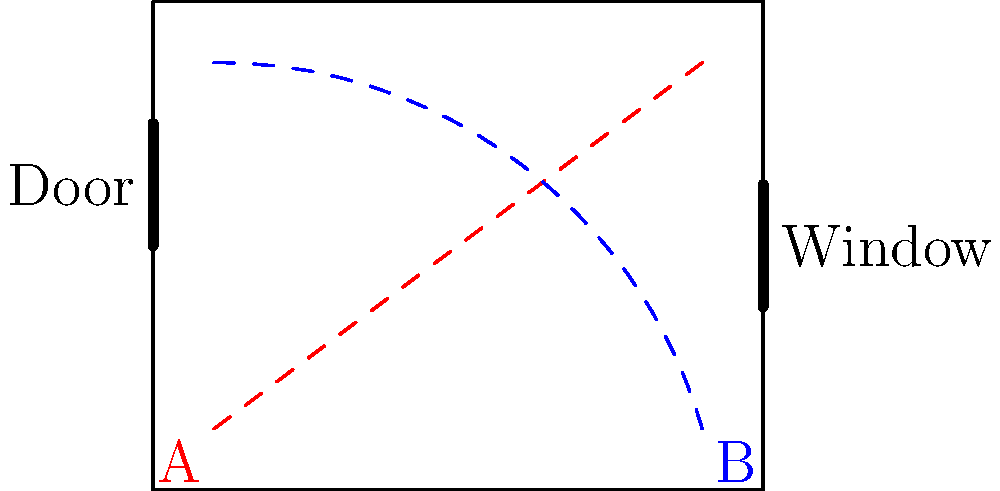In the floor plan diagram of a key film set, two characters' movement patterns are shown. Character A's path is represented by the red dashed line, while Character B's path is shown in blue. Based on these movement patterns, what cinematic technique is likely being employed to create narrative tension, and how does the set layout contribute to this effect? To answer this question, we need to analyze the movement patterns and set layout:

1. Character paths:
   - Character A (red) moves from the bottom-left to the top-right.
   - Character B (blue) moves from the bottom-right to the top-left.

2. Set layout:
   - The room has a door on the left side and a window on the right side.
   - The characters' paths intersect near the center of the room.

3. Cinematic technique analysis:
   - The crossing paths suggest a technique called "cross-cutting" or "parallel action."
   - This technique involves alternating between two or more scenes that often occur simultaneously but in different locations.

4. Narrative tension:
   - The intersecting paths create anticipation of a potential encounter or conflict between the characters.
   - The door and window provide potential entry/exit points, adding to the suspense.

5. Set layout contribution:
   - The rectangular room with limited entry/exit points creates a confined space.
   - This confined space intensifies the feeling of inevitable confrontation.

6. Overall effect:
   - The combination of crossing paths and confined space builds suspense and narrative tension.
   - It suggests that the characters are on a collision course, both literally and figuratively.

Therefore, the likely cinematic technique being employed is cross-cutting or parallel action, with the set layout enhancing the sense of confinement and inevitable confrontation.
Answer: Cross-cutting/parallel action, enhanced by confined set layout 